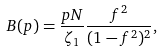<formula> <loc_0><loc_0><loc_500><loc_500>B ( p ) = \frac { p N } { \zeta _ { 1 } } \frac { f ^ { 2 } } { ( 1 - f ^ { 2 } ) ^ { 2 } } ,</formula> 